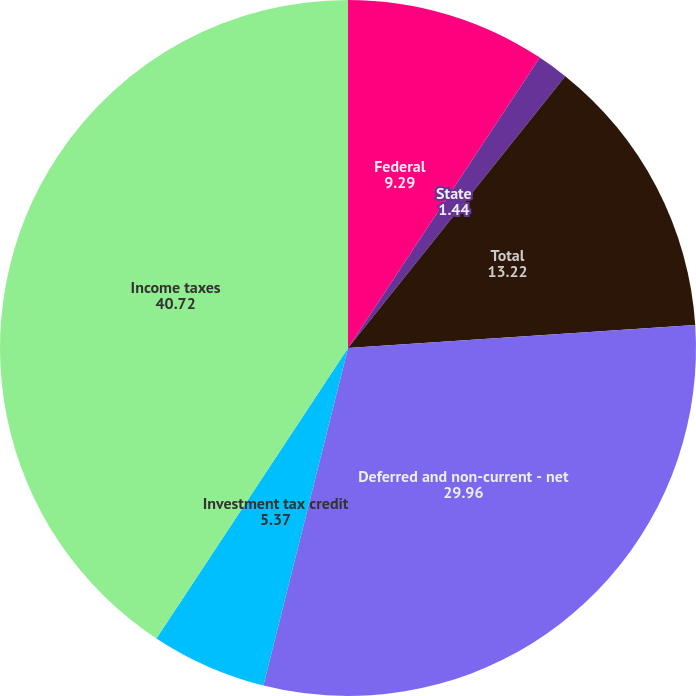Convert chart. <chart><loc_0><loc_0><loc_500><loc_500><pie_chart><fcel>Federal<fcel>State<fcel>Total<fcel>Deferred and non-current - net<fcel>Investment tax credit<fcel>Income taxes<nl><fcel>9.29%<fcel>1.44%<fcel>13.22%<fcel>29.96%<fcel>5.37%<fcel>40.72%<nl></chart> 